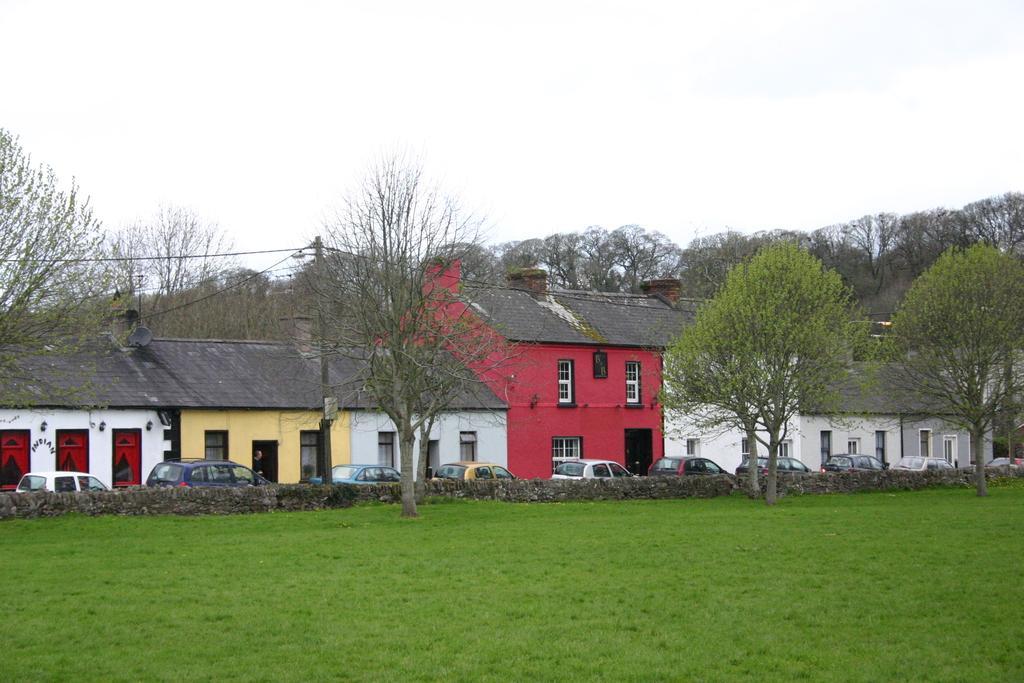How would you summarize this image in a sentence or two? In this image I see houses and I see the cars over here and I see the green grass, wall, trees and I see a pole over here and I see the wires. In the background I see the sky. 